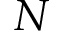Convert formula to latex. <formula><loc_0><loc_0><loc_500><loc_500>N</formula> 